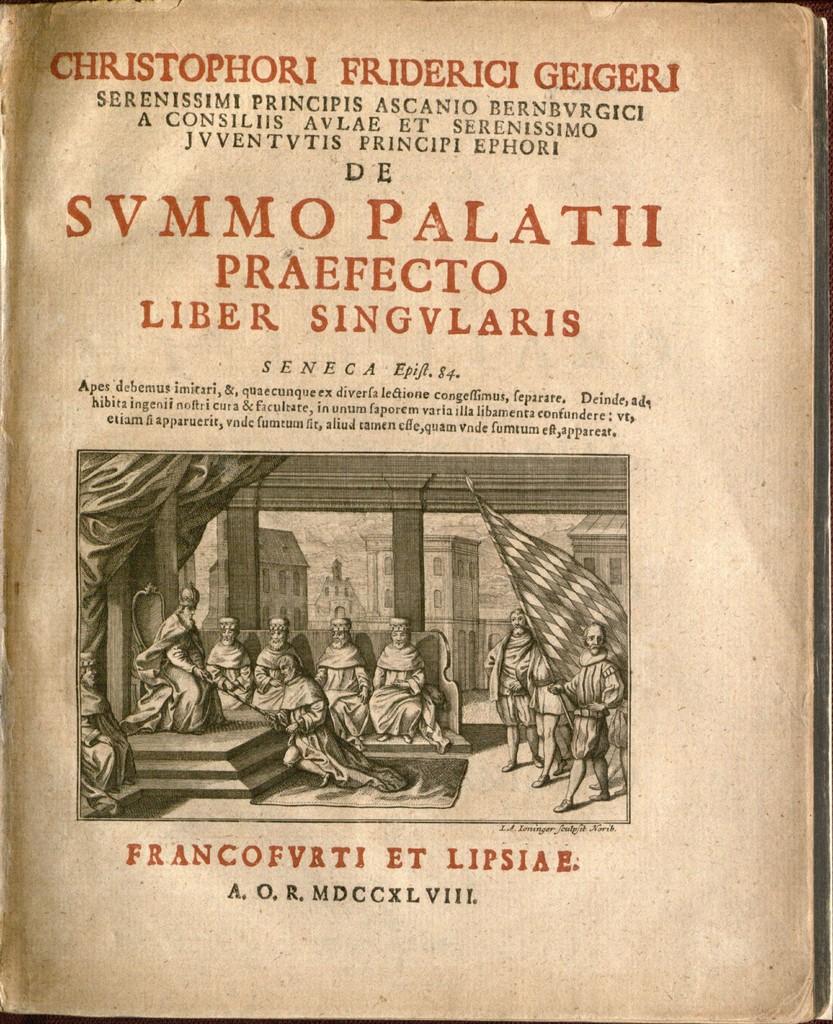What is the latin title of the book?
Keep it short and to the point. Svmmo palatii. 